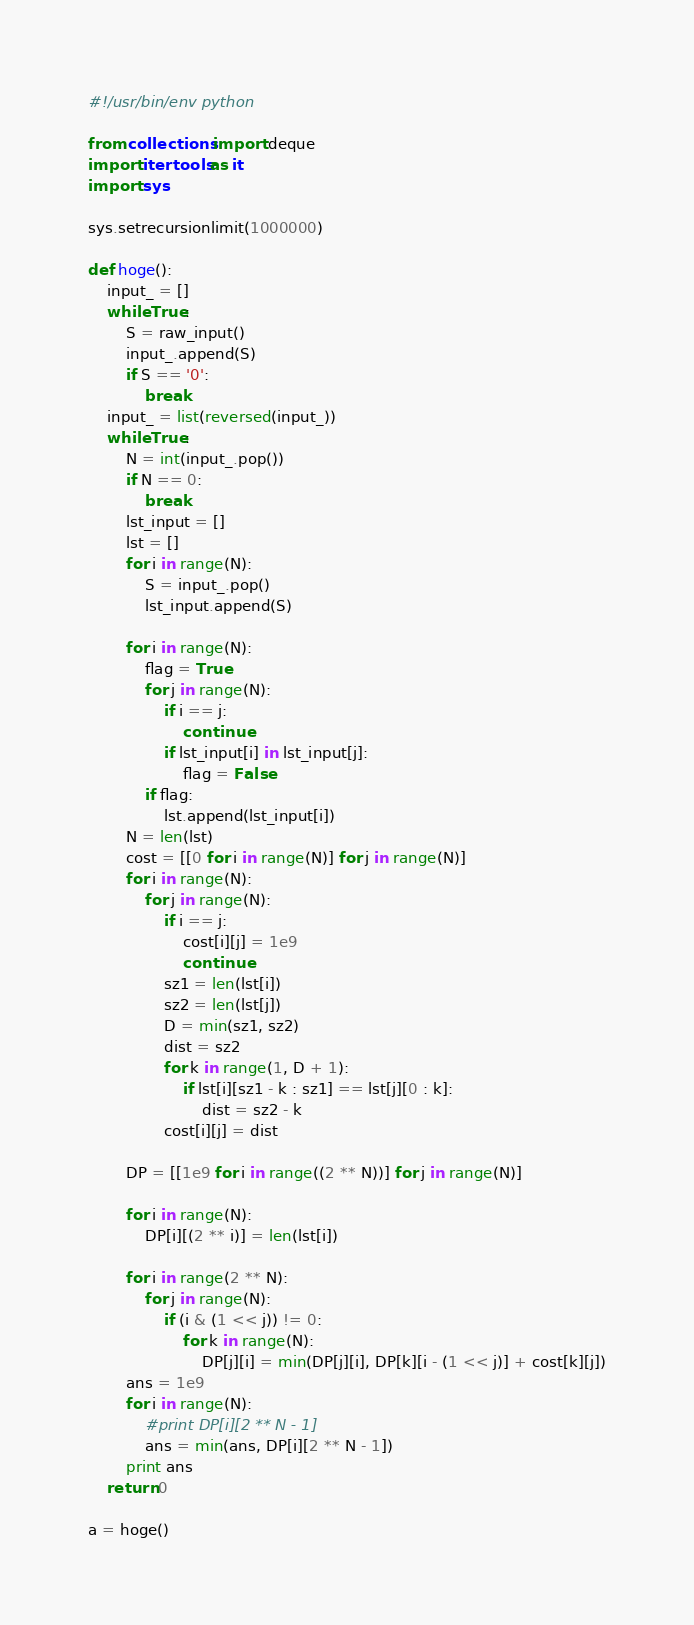<code> <loc_0><loc_0><loc_500><loc_500><_Python_>#!/usr/bin/env python

from collections import deque
import itertools as it
import sys

sys.setrecursionlimit(1000000)

def hoge():
    input_ = []
    while True:
        S = raw_input()
        input_.append(S)
        if S == '0':
            break
    input_ = list(reversed(input_))
    while True:
        N = int(input_.pop())
        if N == 0:
            break
        lst_input = []
        lst = []
        for i in range(N):
            S = input_.pop()
            lst_input.append(S)
        
        for i in range(N):
            flag = True
            for j in range(N):
                if i == j:
                    continue
                if lst_input[i] in lst_input[j]:
                    flag = False
            if flag:
                lst.append(lst_input[i])
        N = len(lst)
        cost = [[0 for i in range(N)] for j in range(N)]
        for i in range(N):
            for j in range(N):
                if i == j:
                    cost[i][j] = 1e9
                    continue
                sz1 = len(lst[i])
                sz2 = len(lst[j])
                D = min(sz1, sz2)
                dist = sz2
                for k in range(1, D + 1):
                    if lst[i][sz1 - k : sz1] == lst[j][0 : k]:
                        dist = sz2 - k
                cost[i][j] = dist
        
        DP = [[1e9 for i in range((2 ** N))] for j in range(N)]

        for i in range(N):
            DP[i][(2 ** i)] = len(lst[i])
        
        for i in range(2 ** N):
            for j in range(N):
                if (i & (1 << j)) != 0:
                    for k in range(N):
                        DP[j][i] = min(DP[j][i], DP[k][i - (1 << j)] + cost[k][j])
        ans = 1e9
        for i in range(N):
            #print DP[i][2 ** N - 1]
            ans = min(ans, DP[i][2 ** N - 1])
        print ans
    return 0

a = hoge()
</code> 